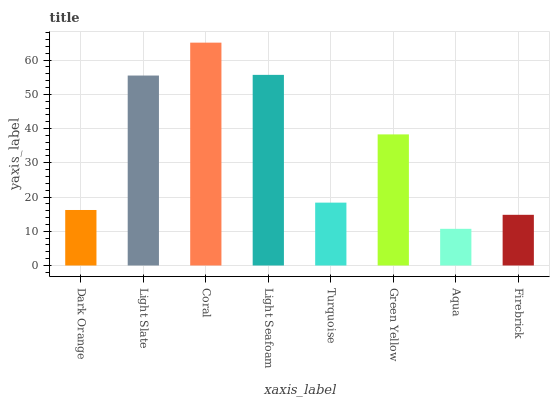Is Light Slate the minimum?
Answer yes or no. No. Is Light Slate the maximum?
Answer yes or no. No. Is Light Slate greater than Dark Orange?
Answer yes or no. Yes. Is Dark Orange less than Light Slate?
Answer yes or no. Yes. Is Dark Orange greater than Light Slate?
Answer yes or no. No. Is Light Slate less than Dark Orange?
Answer yes or no. No. Is Green Yellow the high median?
Answer yes or no. Yes. Is Turquoise the low median?
Answer yes or no. Yes. Is Firebrick the high median?
Answer yes or no. No. Is Firebrick the low median?
Answer yes or no. No. 